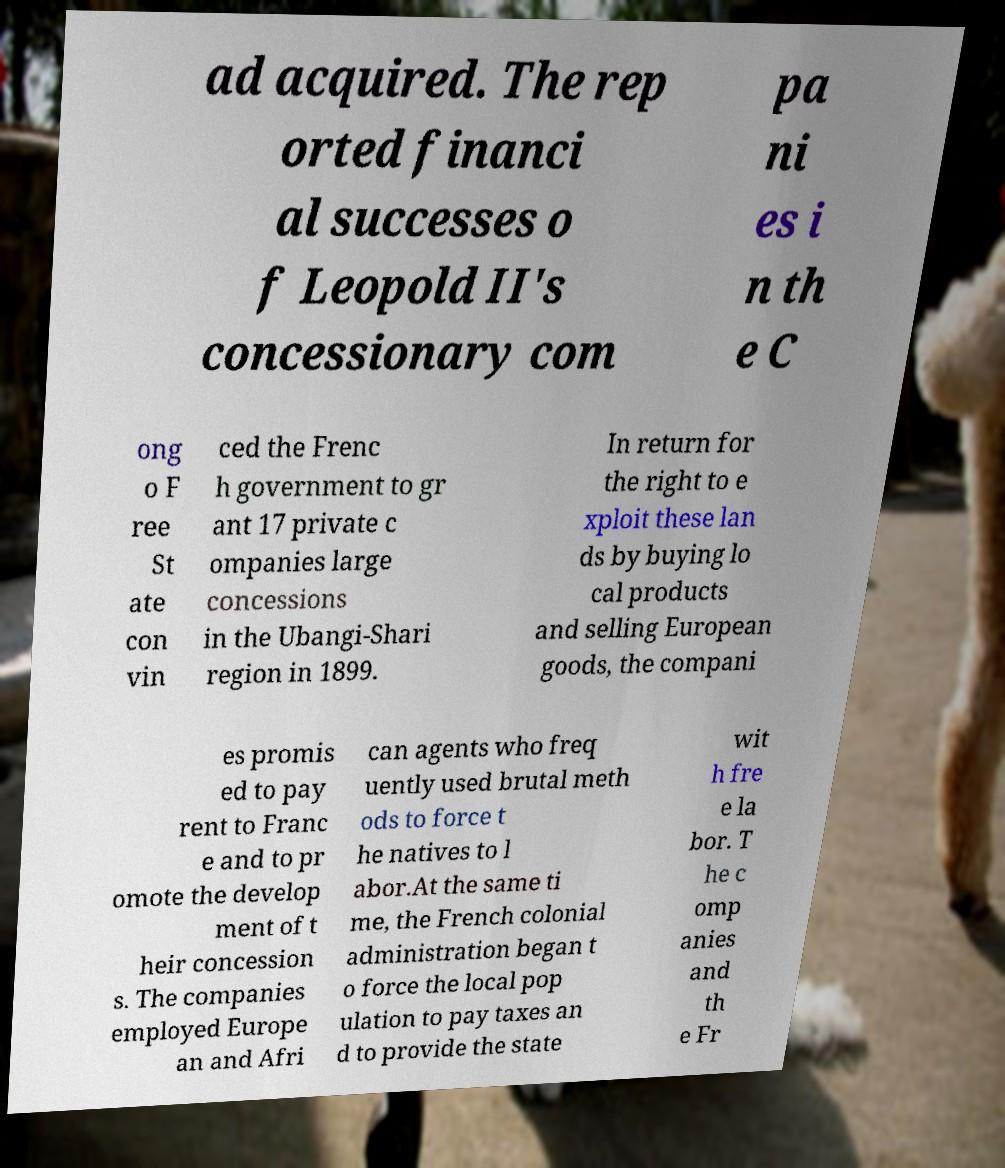Can you read and provide the text displayed in the image?This photo seems to have some interesting text. Can you extract and type it out for me? ad acquired. The rep orted financi al successes o f Leopold II's concessionary com pa ni es i n th e C ong o F ree St ate con vin ced the Frenc h government to gr ant 17 private c ompanies large concessions in the Ubangi-Shari region in 1899. In return for the right to e xploit these lan ds by buying lo cal products and selling European goods, the compani es promis ed to pay rent to Franc e and to pr omote the develop ment of t heir concession s. The companies employed Europe an and Afri can agents who freq uently used brutal meth ods to force t he natives to l abor.At the same ti me, the French colonial administration began t o force the local pop ulation to pay taxes an d to provide the state wit h fre e la bor. T he c omp anies and th e Fr 